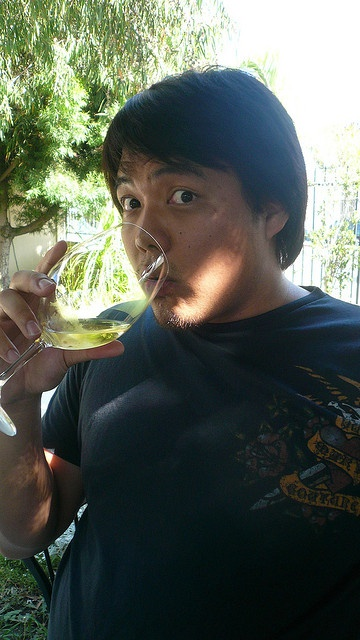Describe the objects in this image and their specific colors. I can see people in black, darkgray, gray, and maroon tones and wine glass in darkgray, ivory, tan, khaki, and gray tones in this image. 